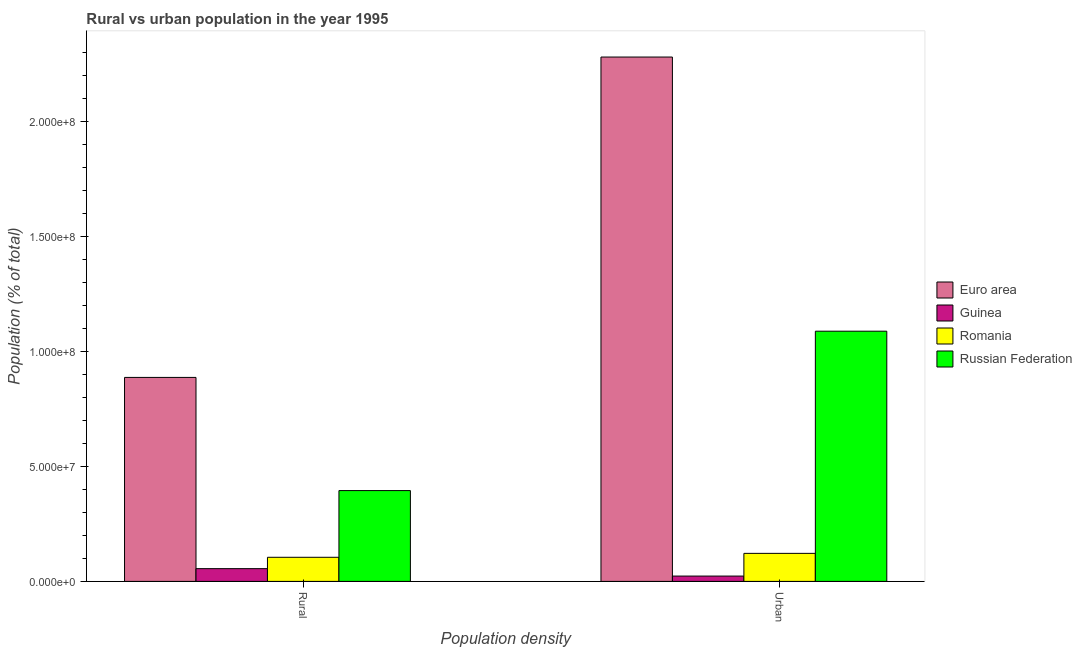How many different coloured bars are there?
Your answer should be very brief. 4. How many bars are there on the 1st tick from the right?
Your response must be concise. 4. What is the label of the 2nd group of bars from the left?
Make the answer very short. Urban. What is the rural population density in Guinea?
Make the answer very short. 5.55e+06. Across all countries, what is the maximum rural population density?
Provide a short and direct response. 8.88e+07. Across all countries, what is the minimum rural population density?
Offer a very short reply. 5.55e+06. In which country was the urban population density maximum?
Ensure brevity in your answer.  Euro area. In which country was the rural population density minimum?
Offer a terse response. Guinea. What is the total urban population density in the graph?
Offer a terse response. 3.52e+08. What is the difference between the rural population density in Romania and that in Guinea?
Provide a succinct answer. 4.94e+06. What is the difference between the rural population density in Russian Federation and the urban population density in Euro area?
Keep it short and to the point. -1.89e+08. What is the average urban population density per country?
Provide a short and direct response. 8.79e+07. What is the difference between the rural population density and urban population density in Euro area?
Your response must be concise. -1.39e+08. What is the ratio of the rural population density in Euro area to that in Guinea?
Your response must be concise. 16.01. Is the urban population density in Russian Federation less than that in Romania?
Keep it short and to the point. No. In how many countries, is the rural population density greater than the average rural population density taken over all countries?
Keep it short and to the point. 2. What does the 4th bar from the left in Rural represents?
Your answer should be very brief. Russian Federation. What does the 2nd bar from the right in Urban represents?
Offer a very short reply. Romania. How many countries are there in the graph?
Your answer should be compact. 4. What is the difference between two consecutive major ticks on the Y-axis?
Ensure brevity in your answer.  5.00e+07. Are the values on the major ticks of Y-axis written in scientific E-notation?
Offer a very short reply. Yes. Does the graph contain grids?
Your answer should be very brief. No. How many legend labels are there?
Provide a short and direct response. 4. How are the legend labels stacked?
Make the answer very short. Vertical. What is the title of the graph?
Offer a very short reply. Rural vs urban population in the year 1995. Does "Angola" appear as one of the legend labels in the graph?
Your response must be concise. No. What is the label or title of the X-axis?
Give a very brief answer. Population density. What is the label or title of the Y-axis?
Your response must be concise. Population (% of total). What is the Population (% of total) of Euro area in Rural?
Make the answer very short. 8.88e+07. What is the Population (% of total) of Guinea in Rural?
Provide a succinct answer. 5.55e+06. What is the Population (% of total) of Romania in Rural?
Give a very brief answer. 1.05e+07. What is the Population (% of total) of Russian Federation in Rural?
Provide a succinct answer. 3.95e+07. What is the Population (% of total) in Euro area in Urban?
Provide a short and direct response. 2.28e+08. What is the Population (% of total) in Guinea in Urban?
Keep it short and to the point. 2.32e+06. What is the Population (% of total) of Romania in Urban?
Your answer should be very brief. 1.22e+07. What is the Population (% of total) of Russian Federation in Urban?
Offer a very short reply. 1.09e+08. Across all Population density, what is the maximum Population (% of total) in Euro area?
Give a very brief answer. 2.28e+08. Across all Population density, what is the maximum Population (% of total) of Guinea?
Ensure brevity in your answer.  5.55e+06. Across all Population density, what is the maximum Population (% of total) of Romania?
Give a very brief answer. 1.22e+07. Across all Population density, what is the maximum Population (% of total) of Russian Federation?
Offer a very short reply. 1.09e+08. Across all Population density, what is the minimum Population (% of total) in Euro area?
Keep it short and to the point. 8.88e+07. Across all Population density, what is the minimum Population (% of total) of Guinea?
Provide a succinct answer. 2.32e+06. Across all Population density, what is the minimum Population (% of total) of Romania?
Offer a very short reply. 1.05e+07. Across all Population density, what is the minimum Population (% of total) in Russian Federation?
Provide a short and direct response. 3.95e+07. What is the total Population (% of total) in Euro area in the graph?
Ensure brevity in your answer.  3.17e+08. What is the total Population (% of total) in Guinea in the graph?
Give a very brief answer. 7.86e+06. What is the total Population (% of total) of Romania in the graph?
Provide a succinct answer. 2.27e+07. What is the total Population (% of total) of Russian Federation in the graph?
Provide a succinct answer. 1.48e+08. What is the difference between the Population (% of total) in Euro area in Rural and that in Urban?
Keep it short and to the point. -1.39e+08. What is the difference between the Population (% of total) of Guinea in Rural and that in Urban?
Keep it short and to the point. 3.23e+06. What is the difference between the Population (% of total) of Romania in Rural and that in Urban?
Ensure brevity in your answer.  -1.71e+06. What is the difference between the Population (% of total) in Russian Federation in Rural and that in Urban?
Offer a terse response. -6.94e+07. What is the difference between the Population (% of total) of Euro area in Rural and the Population (% of total) of Guinea in Urban?
Make the answer very short. 8.64e+07. What is the difference between the Population (% of total) of Euro area in Rural and the Population (% of total) of Romania in Urban?
Offer a terse response. 7.66e+07. What is the difference between the Population (% of total) in Euro area in Rural and the Population (% of total) in Russian Federation in Urban?
Offer a terse response. -2.01e+07. What is the difference between the Population (% of total) of Guinea in Rural and the Population (% of total) of Romania in Urban?
Give a very brief answer. -6.65e+06. What is the difference between the Population (% of total) in Guinea in Rural and the Population (% of total) in Russian Federation in Urban?
Offer a terse response. -1.03e+08. What is the difference between the Population (% of total) of Romania in Rural and the Population (% of total) of Russian Federation in Urban?
Your response must be concise. -9.84e+07. What is the average Population (% of total) of Euro area per Population density?
Your response must be concise. 1.58e+08. What is the average Population (% of total) of Guinea per Population density?
Offer a terse response. 3.93e+06. What is the average Population (% of total) of Romania per Population density?
Ensure brevity in your answer.  1.13e+07. What is the average Population (% of total) in Russian Federation per Population density?
Ensure brevity in your answer.  7.42e+07. What is the difference between the Population (% of total) of Euro area and Population (% of total) of Guinea in Rural?
Offer a terse response. 8.32e+07. What is the difference between the Population (% of total) in Euro area and Population (% of total) in Romania in Rural?
Provide a succinct answer. 7.83e+07. What is the difference between the Population (% of total) in Euro area and Population (% of total) in Russian Federation in Rural?
Offer a terse response. 4.92e+07. What is the difference between the Population (% of total) of Guinea and Population (% of total) of Romania in Rural?
Keep it short and to the point. -4.94e+06. What is the difference between the Population (% of total) of Guinea and Population (% of total) of Russian Federation in Rural?
Provide a succinct answer. -3.40e+07. What is the difference between the Population (% of total) of Romania and Population (% of total) of Russian Federation in Rural?
Offer a very short reply. -2.90e+07. What is the difference between the Population (% of total) of Euro area and Population (% of total) of Guinea in Urban?
Offer a terse response. 2.26e+08. What is the difference between the Population (% of total) of Euro area and Population (% of total) of Romania in Urban?
Provide a short and direct response. 2.16e+08. What is the difference between the Population (% of total) in Euro area and Population (% of total) in Russian Federation in Urban?
Make the answer very short. 1.19e+08. What is the difference between the Population (% of total) in Guinea and Population (% of total) in Romania in Urban?
Offer a terse response. -9.88e+06. What is the difference between the Population (% of total) of Guinea and Population (% of total) of Russian Federation in Urban?
Ensure brevity in your answer.  -1.07e+08. What is the difference between the Population (% of total) of Romania and Population (% of total) of Russian Federation in Urban?
Offer a terse response. -9.67e+07. What is the ratio of the Population (% of total) in Euro area in Rural to that in Urban?
Provide a short and direct response. 0.39. What is the ratio of the Population (% of total) of Guinea in Rural to that in Urban?
Provide a short and direct response. 2.39. What is the ratio of the Population (% of total) in Romania in Rural to that in Urban?
Offer a very short reply. 0.86. What is the ratio of the Population (% of total) in Russian Federation in Rural to that in Urban?
Your answer should be compact. 0.36. What is the difference between the highest and the second highest Population (% of total) in Euro area?
Make the answer very short. 1.39e+08. What is the difference between the highest and the second highest Population (% of total) in Guinea?
Your response must be concise. 3.23e+06. What is the difference between the highest and the second highest Population (% of total) of Romania?
Provide a short and direct response. 1.71e+06. What is the difference between the highest and the second highest Population (% of total) of Russian Federation?
Give a very brief answer. 6.94e+07. What is the difference between the highest and the lowest Population (% of total) in Euro area?
Ensure brevity in your answer.  1.39e+08. What is the difference between the highest and the lowest Population (% of total) in Guinea?
Keep it short and to the point. 3.23e+06. What is the difference between the highest and the lowest Population (% of total) of Romania?
Your response must be concise. 1.71e+06. What is the difference between the highest and the lowest Population (% of total) in Russian Federation?
Provide a short and direct response. 6.94e+07. 